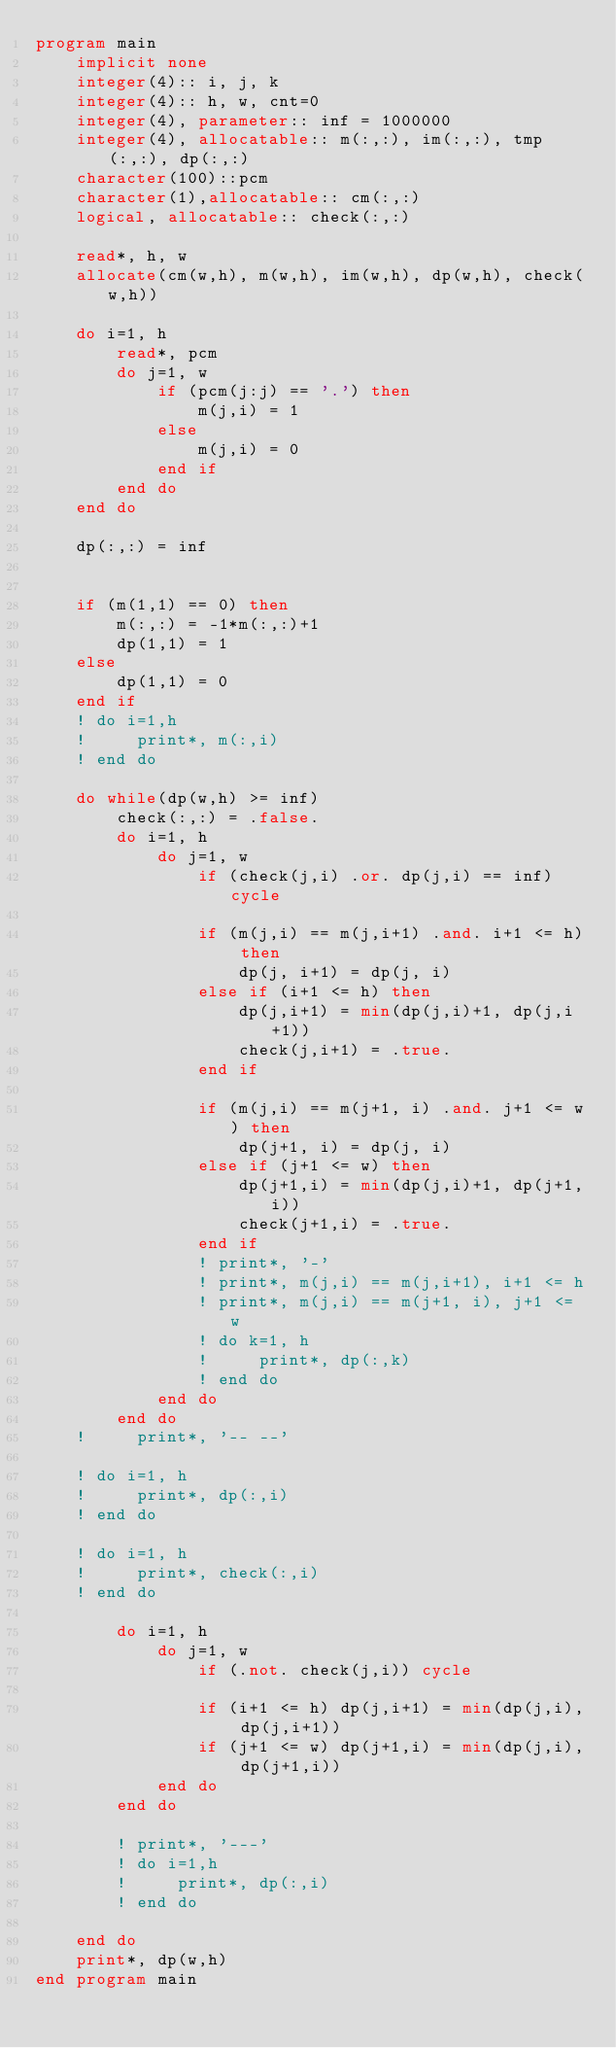<code> <loc_0><loc_0><loc_500><loc_500><_FORTRAN_>program main
    implicit none
    integer(4):: i, j, k
    integer(4):: h, w, cnt=0
    integer(4), parameter:: inf = 1000000
    integer(4), allocatable:: m(:,:), im(:,:), tmp(:,:), dp(:,:)
    character(100)::pcm
    character(1),allocatable:: cm(:,:)
    logical, allocatable:: check(:,:)

    read*, h, w
    allocate(cm(w,h), m(w,h), im(w,h), dp(w,h), check(w,h))

    do i=1, h
        read*, pcm
        do j=1, w
            if (pcm(j:j) == '.') then
                m(j,i) = 1
            else
                m(j,i) = 0
            end if
        end do
    end do

    dp(:,:) = inf


    if (m(1,1) == 0) then
        m(:,:) = -1*m(:,:)+1
        dp(1,1) = 1
    else
        dp(1,1) = 0
    end if
    ! do i=1,h
    !     print*, m(:,i)
    ! end do

    do while(dp(w,h) >= inf)
        check(:,:) = .false.
        do i=1, h
            do j=1, w
                if (check(j,i) .or. dp(j,i) == inf) cycle

                if (m(j,i) == m(j,i+1) .and. i+1 <= h) then
                    dp(j, i+1) = dp(j, i)
                else if (i+1 <= h) then
                    dp(j,i+1) = min(dp(j,i)+1, dp(j,i+1))
                    check(j,i+1) = .true.
                end if

                if (m(j,i) == m(j+1, i) .and. j+1 <= w) then
                    dp(j+1, i) = dp(j, i)
                else if (j+1 <= w) then
                    dp(j+1,i) = min(dp(j,i)+1, dp(j+1,i))
                    check(j+1,i) = .true.
                end if
                ! print*, '-'
                ! print*, m(j,i) == m(j,i+1), i+1 <= h
                ! print*, m(j,i) == m(j+1, i), j+1 <= w
                ! do k=1, h
                !     print*, dp(:,k)
                ! end do
            end do
        end do
    !     print*, '-- --'

    ! do i=1, h
    !     print*, dp(:,i)
    ! end do

    ! do i=1, h
    !     print*, check(:,i)
    ! end do

        do i=1, h
            do j=1, w
                if (.not. check(j,i)) cycle

                if (i+1 <= h) dp(j,i+1) = min(dp(j,i), dp(j,i+1))
                if (j+1 <= w) dp(j+1,i) = min(dp(j,i), dp(j+1,i))
            end do
        end do

        ! print*, '---'
        ! do i=1,h
        !     print*, dp(:,i)
        ! end do

    end do
    print*, dp(w,h)
end program main</code> 